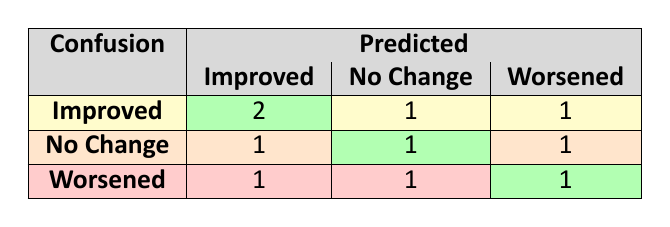What is the number of clients predicted to have "Improved" progress who actually had "Improved" progress? In the confusion matrix, we look at the row for "Improved" actual progress and the column for "Improved" predicted progress, which shows a count of 2.
Answer: 2 How many clients experienced "Worsened" progress but were predicted to have "No Change"? We examine the row for "Worsened" actual progress and look in the "No Change" predicted column, which indicates a count of 1.
Answer: 1 Is it true that more clients had "Worsened" actual progress than were predicted to "Improve"? To determine this, we can count the total number of clients in the "Worsened" row and compare that number to the total in the "Improved" column. There are 3 clients with "Worsened" progress and 3 predicted to "Improve" (2 + 1). So it is false.
Answer: No What is the total number of predictions made for "No Change" progress? We calculate this by adding the values in the "No Change" column across all actual progress categories: 1 (from "Improved") + 1 (from "No Change") + 1 (from "Worsened") = 3.
Answer: 3 If a client is predicted to have "Worsened" progress, what is the actual percentage of those clients who actually "Improved"? In the row for clients predicted to "Worsen," we have two entries: one with actual "Improved" and one with actual "Worsened." The percentage of clients who actually "Improved" is 1 out of 2, which is 50%.
Answer: 50% How many total clients were correctly predicted as "No Change"? We look at the "No Change" row in the matrix and find the green cell, which indicates correct predictions for "No Change": there is 1 client that was accurately predicted as "No Change."
Answer: 1 How many total instances indicate incorrect predictions for clients whose actual progress was "Improved"? We analyze the "Improved" row and find that there are two discrepancies: one was predicted as "No Change" and another as "Worsened." Thus, there are 2 incorrect predictions.
Answer: 2 What is the ratio of clients predicted as "Improved" to those whose actual progress was "Worsened"? The number of clients predicted as "Improved" is 4 (2 from "Improved" row and 2 from "Worsened" row), while the number of clients who actually "Worsened" is 3. Thus, the ratio is 4 to 3.
Answer: 4:3 